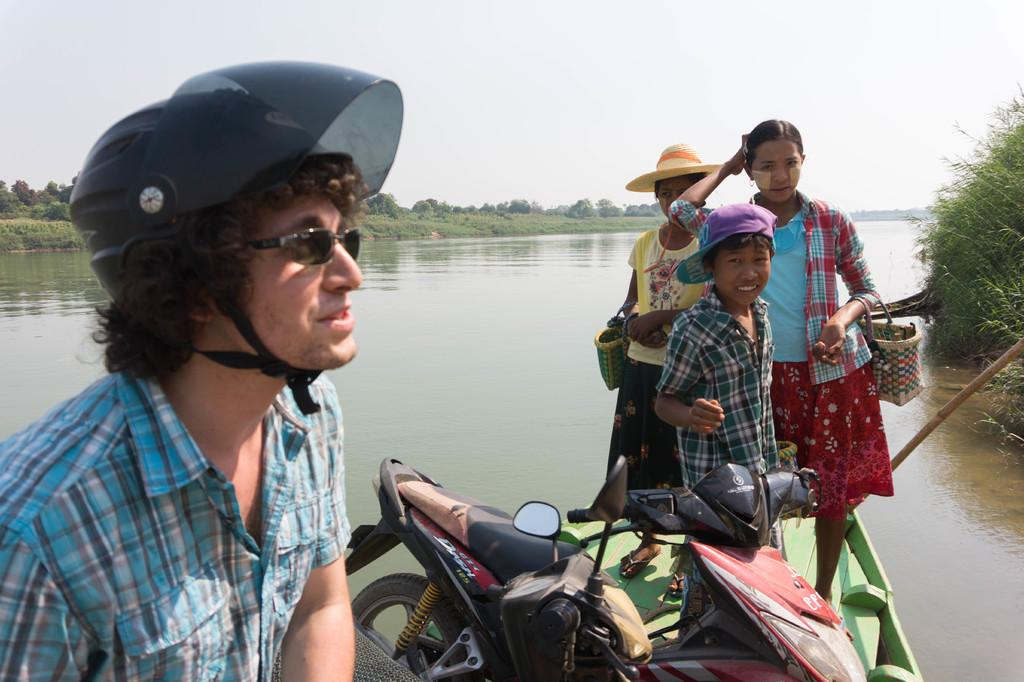Who is present in the image? There is a man in the image. What objects can be seen in the image? There are two bikes in the image. How many children are in the image? There are three children in the image. Where are the children located? The children are on a boat. What is the boat doing? The boat is sailing on a river. What can be seen in the background of the image? There are trees and the sky visible in the background of the image. What part of the boat is being stretched by the children in the image? There is no indication in the image that the children are stretching any part of the boat. 